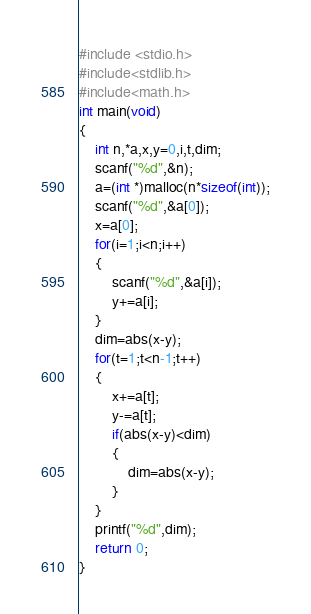<code> <loc_0><loc_0><loc_500><loc_500><_C_>#include <stdio.h>
#include<stdlib.h>
#include<math.h>
int main(void)
{
	int n,*a,x,y=0,i,t,dim;
	scanf("%d",&n);
	a=(int *)malloc(n*sizeof(int));
	scanf("%d",&a[0]);
	x=a[0];
	for(i=1;i<n;i++)
	{
		scanf("%d",&a[i]);
		y+=a[i];
	}
	dim=abs(x-y);
	for(t=1;t<n-1;t++)
	{
		x+=a[t];
	    y-=a[t];
        if(abs(x-y)<dim)
        {
        	dim=abs(x-y);
		}
	}
	printf("%d",dim);
	return 0;
}</code> 